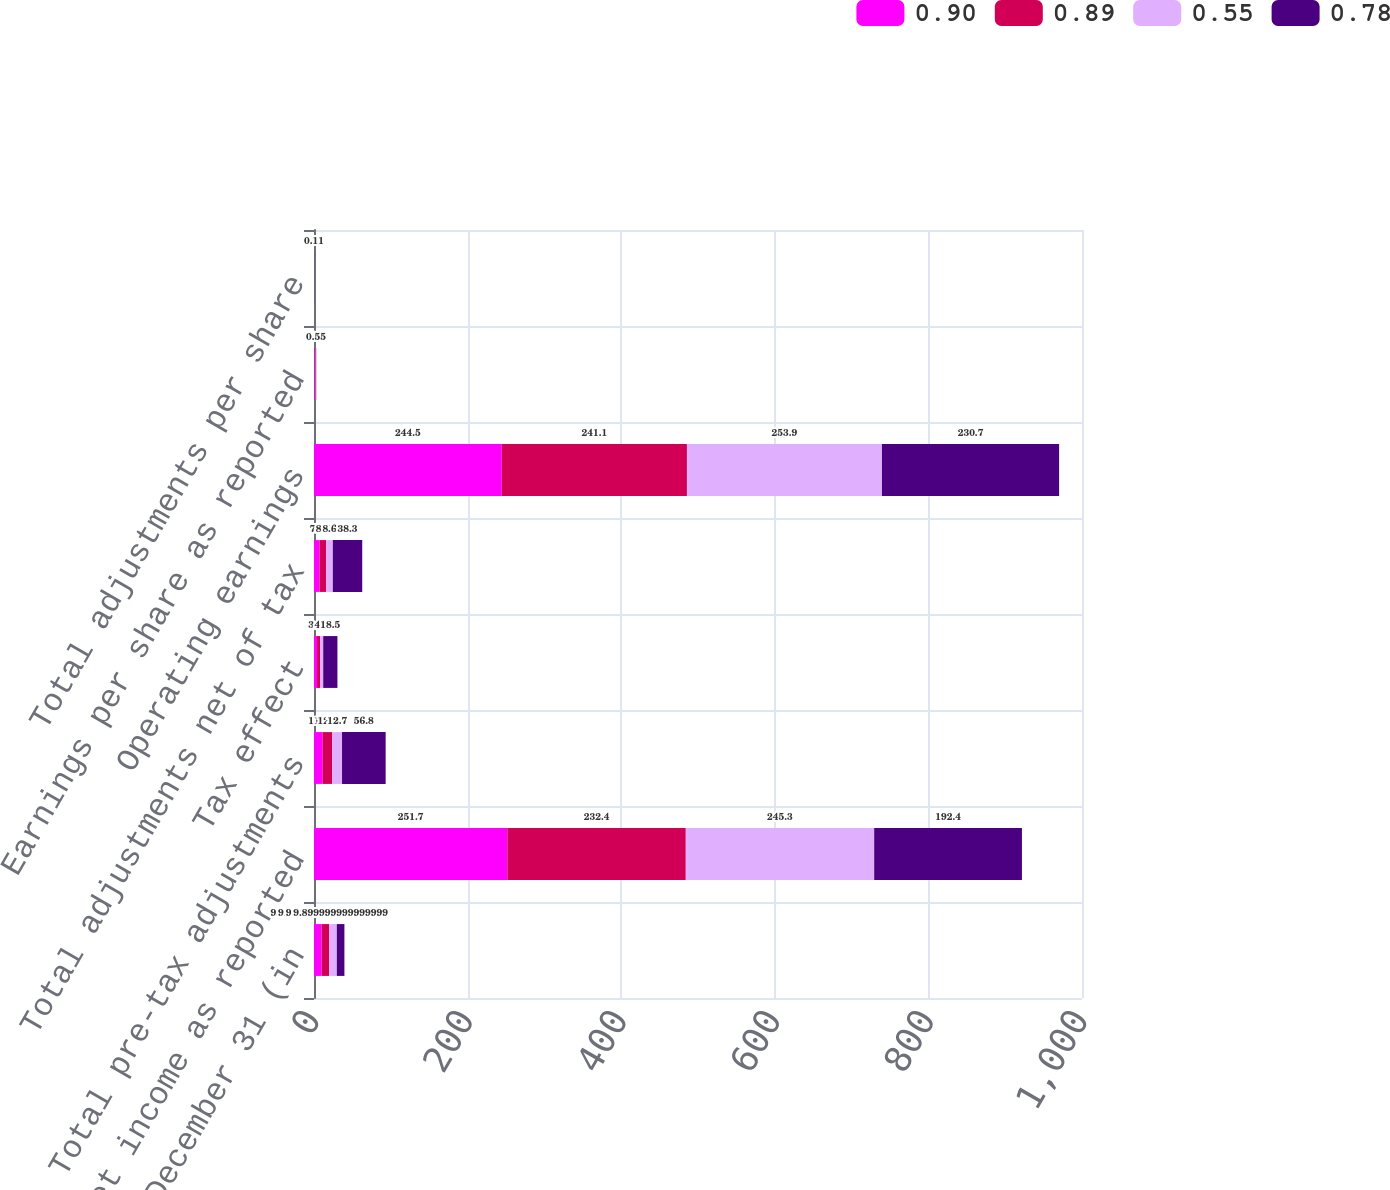Convert chart. <chart><loc_0><loc_0><loc_500><loc_500><stacked_bar_chart><ecel><fcel>Years ended December 31 (in<fcel>Net income as reported<fcel>Total pre-tax adjustments<fcel>Tax effect<fcel>Total adjustments net of tax<fcel>Operating earnings<fcel>Earnings per share as reported<fcel>Total adjustments per share<nl><fcel>0.9<fcel>9.9<fcel>251.7<fcel>11.1<fcel>3.9<fcel>7.2<fcel>244.5<fcel>0.84<fcel>0.02<nl><fcel>0.89<fcel>9.9<fcel>232.4<fcel>12.7<fcel>4<fcel>8.7<fcel>241.1<fcel>0.74<fcel>0.03<nl><fcel>0.55<fcel>9.9<fcel>245.3<fcel>12.7<fcel>4.1<fcel>8.6<fcel>253.9<fcel>0.72<fcel>0.03<nl><fcel>0.78<fcel>9.9<fcel>192.4<fcel>56.8<fcel>18.5<fcel>38.3<fcel>230.7<fcel>0.55<fcel>0.11<nl></chart> 